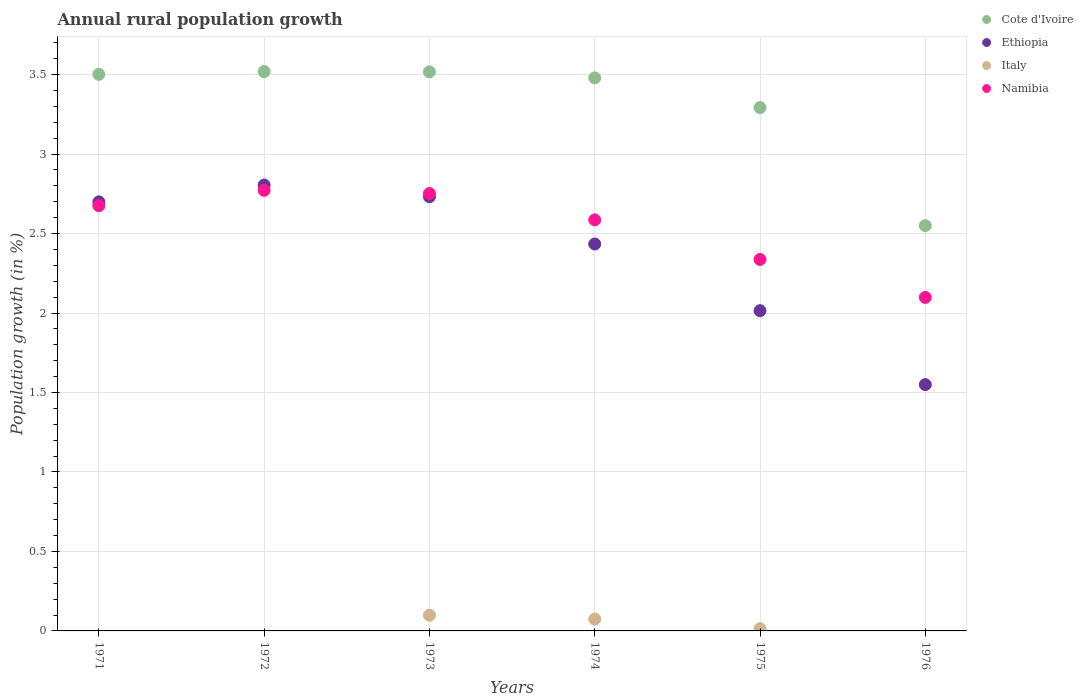How many different coloured dotlines are there?
Your answer should be very brief. 4. Is the number of dotlines equal to the number of legend labels?
Provide a succinct answer. No. What is the percentage of rural population growth in Namibia in 1971?
Keep it short and to the point. 2.68. Across all years, what is the maximum percentage of rural population growth in Namibia?
Provide a succinct answer. 2.77. Across all years, what is the minimum percentage of rural population growth in Ethiopia?
Offer a terse response. 1.55. What is the total percentage of rural population growth in Ethiopia in the graph?
Give a very brief answer. 14.23. What is the difference between the percentage of rural population growth in Cote d'Ivoire in 1974 and that in 1975?
Offer a very short reply. 0.19. What is the difference between the percentage of rural population growth in Cote d'Ivoire in 1973 and the percentage of rural population growth in Ethiopia in 1974?
Offer a very short reply. 1.08. What is the average percentage of rural population growth in Italy per year?
Your response must be concise. 0.03. In the year 1972, what is the difference between the percentage of rural population growth in Ethiopia and percentage of rural population growth in Cote d'Ivoire?
Offer a very short reply. -0.71. What is the ratio of the percentage of rural population growth in Ethiopia in 1972 to that in 1973?
Give a very brief answer. 1.03. Is the percentage of rural population growth in Cote d'Ivoire in 1972 less than that in 1973?
Make the answer very short. No. Is the difference between the percentage of rural population growth in Ethiopia in 1971 and 1976 greater than the difference between the percentage of rural population growth in Cote d'Ivoire in 1971 and 1976?
Keep it short and to the point. Yes. What is the difference between the highest and the second highest percentage of rural population growth in Italy?
Give a very brief answer. 0.02. What is the difference between the highest and the lowest percentage of rural population growth in Italy?
Your answer should be very brief. 0.1. In how many years, is the percentage of rural population growth in Ethiopia greater than the average percentage of rural population growth in Ethiopia taken over all years?
Your response must be concise. 4. Does the percentage of rural population growth in Cote d'Ivoire monotonically increase over the years?
Ensure brevity in your answer.  No. Is the percentage of rural population growth in Ethiopia strictly greater than the percentage of rural population growth in Italy over the years?
Give a very brief answer. Yes. How many years are there in the graph?
Provide a succinct answer. 6. What is the difference between two consecutive major ticks on the Y-axis?
Your answer should be compact. 0.5. Does the graph contain any zero values?
Your answer should be very brief. Yes. How many legend labels are there?
Provide a short and direct response. 4. How are the legend labels stacked?
Your response must be concise. Vertical. What is the title of the graph?
Keep it short and to the point. Annual rural population growth. Does "Grenada" appear as one of the legend labels in the graph?
Provide a short and direct response. No. What is the label or title of the X-axis?
Your answer should be compact. Years. What is the label or title of the Y-axis?
Make the answer very short. Population growth (in %). What is the Population growth (in %) in Cote d'Ivoire in 1971?
Your answer should be very brief. 3.5. What is the Population growth (in %) in Ethiopia in 1971?
Your response must be concise. 2.7. What is the Population growth (in %) in Italy in 1971?
Provide a short and direct response. 0. What is the Population growth (in %) in Namibia in 1971?
Provide a short and direct response. 2.68. What is the Population growth (in %) of Cote d'Ivoire in 1972?
Offer a very short reply. 3.52. What is the Population growth (in %) of Ethiopia in 1972?
Ensure brevity in your answer.  2.81. What is the Population growth (in %) in Italy in 1972?
Ensure brevity in your answer.  0. What is the Population growth (in %) of Namibia in 1972?
Your answer should be very brief. 2.77. What is the Population growth (in %) of Cote d'Ivoire in 1973?
Your response must be concise. 3.52. What is the Population growth (in %) of Ethiopia in 1973?
Keep it short and to the point. 2.73. What is the Population growth (in %) of Italy in 1973?
Offer a very short reply. 0.1. What is the Population growth (in %) of Namibia in 1973?
Your answer should be very brief. 2.75. What is the Population growth (in %) of Cote d'Ivoire in 1974?
Offer a very short reply. 3.48. What is the Population growth (in %) of Ethiopia in 1974?
Offer a very short reply. 2.43. What is the Population growth (in %) of Italy in 1974?
Offer a terse response. 0.07. What is the Population growth (in %) of Namibia in 1974?
Give a very brief answer. 2.59. What is the Population growth (in %) in Cote d'Ivoire in 1975?
Your answer should be compact. 3.29. What is the Population growth (in %) of Ethiopia in 1975?
Provide a succinct answer. 2.01. What is the Population growth (in %) in Italy in 1975?
Provide a short and direct response. 0.01. What is the Population growth (in %) in Namibia in 1975?
Provide a short and direct response. 2.34. What is the Population growth (in %) of Cote d'Ivoire in 1976?
Offer a very short reply. 2.55. What is the Population growth (in %) in Ethiopia in 1976?
Your response must be concise. 1.55. What is the Population growth (in %) in Italy in 1976?
Your answer should be compact. 0. What is the Population growth (in %) of Namibia in 1976?
Your answer should be very brief. 2.1. Across all years, what is the maximum Population growth (in %) of Cote d'Ivoire?
Your response must be concise. 3.52. Across all years, what is the maximum Population growth (in %) of Ethiopia?
Offer a terse response. 2.81. Across all years, what is the maximum Population growth (in %) in Italy?
Offer a very short reply. 0.1. Across all years, what is the maximum Population growth (in %) of Namibia?
Provide a succinct answer. 2.77. Across all years, what is the minimum Population growth (in %) in Cote d'Ivoire?
Your answer should be very brief. 2.55. Across all years, what is the minimum Population growth (in %) in Ethiopia?
Provide a short and direct response. 1.55. Across all years, what is the minimum Population growth (in %) in Namibia?
Provide a succinct answer. 2.1. What is the total Population growth (in %) in Cote d'Ivoire in the graph?
Provide a succinct answer. 19.86. What is the total Population growth (in %) in Ethiopia in the graph?
Make the answer very short. 14.23. What is the total Population growth (in %) in Italy in the graph?
Provide a short and direct response. 0.19. What is the total Population growth (in %) in Namibia in the graph?
Provide a short and direct response. 15.22. What is the difference between the Population growth (in %) of Cote d'Ivoire in 1971 and that in 1972?
Make the answer very short. -0.02. What is the difference between the Population growth (in %) of Ethiopia in 1971 and that in 1972?
Your answer should be very brief. -0.11. What is the difference between the Population growth (in %) in Namibia in 1971 and that in 1972?
Give a very brief answer. -0.1. What is the difference between the Population growth (in %) in Cote d'Ivoire in 1971 and that in 1973?
Offer a very short reply. -0.02. What is the difference between the Population growth (in %) of Ethiopia in 1971 and that in 1973?
Your answer should be compact. -0.03. What is the difference between the Population growth (in %) in Namibia in 1971 and that in 1973?
Give a very brief answer. -0.08. What is the difference between the Population growth (in %) of Cote d'Ivoire in 1971 and that in 1974?
Keep it short and to the point. 0.02. What is the difference between the Population growth (in %) in Ethiopia in 1971 and that in 1974?
Your answer should be compact. 0.27. What is the difference between the Population growth (in %) of Namibia in 1971 and that in 1974?
Ensure brevity in your answer.  0.09. What is the difference between the Population growth (in %) of Cote d'Ivoire in 1971 and that in 1975?
Your response must be concise. 0.21. What is the difference between the Population growth (in %) in Ethiopia in 1971 and that in 1975?
Offer a very short reply. 0.68. What is the difference between the Population growth (in %) in Namibia in 1971 and that in 1975?
Your response must be concise. 0.34. What is the difference between the Population growth (in %) of Cote d'Ivoire in 1971 and that in 1976?
Ensure brevity in your answer.  0.95. What is the difference between the Population growth (in %) in Ethiopia in 1971 and that in 1976?
Provide a short and direct response. 1.15. What is the difference between the Population growth (in %) in Namibia in 1971 and that in 1976?
Keep it short and to the point. 0.58. What is the difference between the Population growth (in %) in Cote d'Ivoire in 1972 and that in 1973?
Make the answer very short. 0. What is the difference between the Population growth (in %) of Ethiopia in 1972 and that in 1973?
Provide a short and direct response. 0.07. What is the difference between the Population growth (in %) of Namibia in 1972 and that in 1973?
Keep it short and to the point. 0.02. What is the difference between the Population growth (in %) of Cote d'Ivoire in 1972 and that in 1974?
Your answer should be compact. 0.04. What is the difference between the Population growth (in %) in Ethiopia in 1972 and that in 1974?
Ensure brevity in your answer.  0.37. What is the difference between the Population growth (in %) in Namibia in 1972 and that in 1974?
Provide a short and direct response. 0.19. What is the difference between the Population growth (in %) of Cote d'Ivoire in 1972 and that in 1975?
Keep it short and to the point. 0.23. What is the difference between the Population growth (in %) of Ethiopia in 1972 and that in 1975?
Your answer should be compact. 0.79. What is the difference between the Population growth (in %) of Namibia in 1972 and that in 1975?
Offer a very short reply. 0.43. What is the difference between the Population growth (in %) in Cote d'Ivoire in 1972 and that in 1976?
Keep it short and to the point. 0.97. What is the difference between the Population growth (in %) of Ethiopia in 1972 and that in 1976?
Keep it short and to the point. 1.26. What is the difference between the Population growth (in %) in Namibia in 1972 and that in 1976?
Give a very brief answer. 0.67. What is the difference between the Population growth (in %) of Cote d'Ivoire in 1973 and that in 1974?
Provide a short and direct response. 0.04. What is the difference between the Population growth (in %) of Ethiopia in 1973 and that in 1974?
Make the answer very short. 0.3. What is the difference between the Population growth (in %) of Italy in 1973 and that in 1974?
Your response must be concise. 0.02. What is the difference between the Population growth (in %) of Namibia in 1973 and that in 1974?
Ensure brevity in your answer.  0.17. What is the difference between the Population growth (in %) of Cote d'Ivoire in 1973 and that in 1975?
Keep it short and to the point. 0.23. What is the difference between the Population growth (in %) of Ethiopia in 1973 and that in 1975?
Make the answer very short. 0.72. What is the difference between the Population growth (in %) of Italy in 1973 and that in 1975?
Keep it short and to the point. 0.08. What is the difference between the Population growth (in %) in Namibia in 1973 and that in 1975?
Offer a very short reply. 0.41. What is the difference between the Population growth (in %) in Cote d'Ivoire in 1973 and that in 1976?
Your answer should be very brief. 0.97. What is the difference between the Population growth (in %) of Ethiopia in 1973 and that in 1976?
Keep it short and to the point. 1.18. What is the difference between the Population growth (in %) of Namibia in 1973 and that in 1976?
Keep it short and to the point. 0.65. What is the difference between the Population growth (in %) of Cote d'Ivoire in 1974 and that in 1975?
Your answer should be compact. 0.19. What is the difference between the Population growth (in %) of Ethiopia in 1974 and that in 1975?
Your answer should be compact. 0.42. What is the difference between the Population growth (in %) of Italy in 1974 and that in 1975?
Your answer should be compact. 0.06. What is the difference between the Population growth (in %) of Namibia in 1974 and that in 1975?
Provide a succinct answer. 0.25. What is the difference between the Population growth (in %) of Cote d'Ivoire in 1974 and that in 1976?
Provide a succinct answer. 0.93. What is the difference between the Population growth (in %) in Ethiopia in 1974 and that in 1976?
Give a very brief answer. 0.88. What is the difference between the Population growth (in %) of Namibia in 1974 and that in 1976?
Offer a very short reply. 0.49. What is the difference between the Population growth (in %) in Cote d'Ivoire in 1975 and that in 1976?
Your answer should be compact. 0.74. What is the difference between the Population growth (in %) in Ethiopia in 1975 and that in 1976?
Make the answer very short. 0.46. What is the difference between the Population growth (in %) of Namibia in 1975 and that in 1976?
Provide a succinct answer. 0.24. What is the difference between the Population growth (in %) in Cote d'Ivoire in 1971 and the Population growth (in %) in Ethiopia in 1972?
Make the answer very short. 0.7. What is the difference between the Population growth (in %) of Cote d'Ivoire in 1971 and the Population growth (in %) of Namibia in 1972?
Your answer should be very brief. 0.73. What is the difference between the Population growth (in %) in Ethiopia in 1971 and the Population growth (in %) in Namibia in 1972?
Give a very brief answer. -0.07. What is the difference between the Population growth (in %) in Cote d'Ivoire in 1971 and the Population growth (in %) in Ethiopia in 1973?
Your answer should be compact. 0.77. What is the difference between the Population growth (in %) of Cote d'Ivoire in 1971 and the Population growth (in %) of Italy in 1973?
Your answer should be compact. 3.4. What is the difference between the Population growth (in %) in Cote d'Ivoire in 1971 and the Population growth (in %) in Namibia in 1973?
Offer a terse response. 0.75. What is the difference between the Population growth (in %) in Ethiopia in 1971 and the Population growth (in %) in Italy in 1973?
Ensure brevity in your answer.  2.6. What is the difference between the Population growth (in %) in Ethiopia in 1971 and the Population growth (in %) in Namibia in 1973?
Offer a terse response. -0.05. What is the difference between the Population growth (in %) of Cote d'Ivoire in 1971 and the Population growth (in %) of Ethiopia in 1974?
Provide a succinct answer. 1.07. What is the difference between the Population growth (in %) of Cote d'Ivoire in 1971 and the Population growth (in %) of Italy in 1974?
Offer a terse response. 3.43. What is the difference between the Population growth (in %) in Cote d'Ivoire in 1971 and the Population growth (in %) in Namibia in 1974?
Your answer should be compact. 0.92. What is the difference between the Population growth (in %) in Ethiopia in 1971 and the Population growth (in %) in Italy in 1974?
Provide a short and direct response. 2.62. What is the difference between the Population growth (in %) of Ethiopia in 1971 and the Population growth (in %) of Namibia in 1974?
Keep it short and to the point. 0.11. What is the difference between the Population growth (in %) in Cote d'Ivoire in 1971 and the Population growth (in %) in Ethiopia in 1975?
Offer a very short reply. 1.49. What is the difference between the Population growth (in %) of Cote d'Ivoire in 1971 and the Population growth (in %) of Italy in 1975?
Keep it short and to the point. 3.49. What is the difference between the Population growth (in %) of Cote d'Ivoire in 1971 and the Population growth (in %) of Namibia in 1975?
Provide a succinct answer. 1.16. What is the difference between the Population growth (in %) in Ethiopia in 1971 and the Population growth (in %) in Italy in 1975?
Keep it short and to the point. 2.69. What is the difference between the Population growth (in %) of Ethiopia in 1971 and the Population growth (in %) of Namibia in 1975?
Provide a short and direct response. 0.36. What is the difference between the Population growth (in %) in Cote d'Ivoire in 1971 and the Population growth (in %) in Ethiopia in 1976?
Your answer should be compact. 1.95. What is the difference between the Population growth (in %) in Cote d'Ivoire in 1971 and the Population growth (in %) in Namibia in 1976?
Make the answer very short. 1.4. What is the difference between the Population growth (in %) in Ethiopia in 1971 and the Population growth (in %) in Namibia in 1976?
Provide a succinct answer. 0.6. What is the difference between the Population growth (in %) in Cote d'Ivoire in 1972 and the Population growth (in %) in Ethiopia in 1973?
Offer a terse response. 0.79. What is the difference between the Population growth (in %) in Cote d'Ivoire in 1972 and the Population growth (in %) in Italy in 1973?
Ensure brevity in your answer.  3.42. What is the difference between the Population growth (in %) of Cote d'Ivoire in 1972 and the Population growth (in %) of Namibia in 1973?
Provide a succinct answer. 0.77. What is the difference between the Population growth (in %) in Ethiopia in 1972 and the Population growth (in %) in Italy in 1973?
Provide a succinct answer. 2.71. What is the difference between the Population growth (in %) in Ethiopia in 1972 and the Population growth (in %) in Namibia in 1973?
Keep it short and to the point. 0.05. What is the difference between the Population growth (in %) of Cote d'Ivoire in 1972 and the Population growth (in %) of Ethiopia in 1974?
Your response must be concise. 1.08. What is the difference between the Population growth (in %) in Cote d'Ivoire in 1972 and the Population growth (in %) in Italy in 1974?
Provide a succinct answer. 3.44. What is the difference between the Population growth (in %) in Cote d'Ivoire in 1972 and the Population growth (in %) in Namibia in 1974?
Offer a terse response. 0.93. What is the difference between the Population growth (in %) of Ethiopia in 1972 and the Population growth (in %) of Italy in 1974?
Provide a short and direct response. 2.73. What is the difference between the Population growth (in %) of Ethiopia in 1972 and the Population growth (in %) of Namibia in 1974?
Your answer should be very brief. 0.22. What is the difference between the Population growth (in %) in Cote d'Ivoire in 1972 and the Population growth (in %) in Ethiopia in 1975?
Offer a terse response. 1.5. What is the difference between the Population growth (in %) in Cote d'Ivoire in 1972 and the Population growth (in %) in Italy in 1975?
Your response must be concise. 3.51. What is the difference between the Population growth (in %) of Cote d'Ivoire in 1972 and the Population growth (in %) of Namibia in 1975?
Keep it short and to the point. 1.18. What is the difference between the Population growth (in %) of Ethiopia in 1972 and the Population growth (in %) of Italy in 1975?
Your answer should be compact. 2.79. What is the difference between the Population growth (in %) in Ethiopia in 1972 and the Population growth (in %) in Namibia in 1975?
Provide a short and direct response. 0.47. What is the difference between the Population growth (in %) of Cote d'Ivoire in 1972 and the Population growth (in %) of Ethiopia in 1976?
Ensure brevity in your answer.  1.97. What is the difference between the Population growth (in %) of Cote d'Ivoire in 1972 and the Population growth (in %) of Namibia in 1976?
Your answer should be compact. 1.42. What is the difference between the Population growth (in %) in Ethiopia in 1972 and the Population growth (in %) in Namibia in 1976?
Offer a terse response. 0.71. What is the difference between the Population growth (in %) of Cote d'Ivoire in 1973 and the Population growth (in %) of Ethiopia in 1974?
Offer a terse response. 1.08. What is the difference between the Population growth (in %) in Cote d'Ivoire in 1973 and the Population growth (in %) in Italy in 1974?
Your answer should be compact. 3.44. What is the difference between the Population growth (in %) of Cote d'Ivoire in 1973 and the Population growth (in %) of Namibia in 1974?
Your answer should be compact. 0.93. What is the difference between the Population growth (in %) in Ethiopia in 1973 and the Population growth (in %) in Italy in 1974?
Give a very brief answer. 2.66. What is the difference between the Population growth (in %) of Ethiopia in 1973 and the Population growth (in %) of Namibia in 1974?
Offer a very short reply. 0.15. What is the difference between the Population growth (in %) of Italy in 1973 and the Population growth (in %) of Namibia in 1974?
Provide a succinct answer. -2.49. What is the difference between the Population growth (in %) in Cote d'Ivoire in 1973 and the Population growth (in %) in Ethiopia in 1975?
Provide a succinct answer. 1.5. What is the difference between the Population growth (in %) of Cote d'Ivoire in 1973 and the Population growth (in %) of Italy in 1975?
Offer a terse response. 3.5. What is the difference between the Population growth (in %) in Cote d'Ivoire in 1973 and the Population growth (in %) in Namibia in 1975?
Offer a very short reply. 1.18. What is the difference between the Population growth (in %) of Ethiopia in 1973 and the Population growth (in %) of Italy in 1975?
Provide a short and direct response. 2.72. What is the difference between the Population growth (in %) in Ethiopia in 1973 and the Population growth (in %) in Namibia in 1975?
Provide a short and direct response. 0.39. What is the difference between the Population growth (in %) of Italy in 1973 and the Population growth (in %) of Namibia in 1975?
Give a very brief answer. -2.24. What is the difference between the Population growth (in %) in Cote d'Ivoire in 1973 and the Population growth (in %) in Ethiopia in 1976?
Your answer should be very brief. 1.97. What is the difference between the Population growth (in %) of Cote d'Ivoire in 1973 and the Population growth (in %) of Namibia in 1976?
Provide a succinct answer. 1.42. What is the difference between the Population growth (in %) in Ethiopia in 1973 and the Population growth (in %) in Namibia in 1976?
Give a very brief answer. 0.63. What is the difference between the Population growth (in %) of Italy in 1973 and the Population growth (in %) of Namibia in 1976?
Your response must be concise. -2. What is the difference between the Population growth (in %) in Cote d'Ivoire in 1974 and the Population growth (in %) in Ethiopia in 1975?
Provide a short and direct response. 1.46. What is the difference between the Population growth (in %) of Cote d'Ivoire in 1974 and the Population growth (in %) of Italy in 1975?
Make the answer very short. 3.47. What is the difference between the Population growth (in %) in Cote d'Ivoire in 1974 and the Population growth (in %) in Namibia in 1975?
Provide a succinct answer. 1.14. What is the difference between the Population growth (in %) of Ethiopia in 1974 and the Population growth (in %) of Italy in 1975?
Make the answer very short. 2.42. What is the difference between the Population growth (in %) of Ethiopia in 1974 and the Population growth (in %) of Namibia in 1975?
Your answer should be compact. 0.1. What is the difference between the Population growth (in %) of Italy in 1974 and the Population growth (in %) of Namibia in 1975?
Your response must be concise. -2.26. What is the difference between the Population growth (in %) in Cote d'Ivoire in 1974 and the Population growth (in %) in Ethiopia in 1976?
Give a very brief answer. 1.93. What is the difference between the Population growth (in %) of Cote d'Ivoire in 1974 and the Population growth (in %) of Namibia in 1976?
Ensure brevity in your answer.  1.38. What is the difference between the Population growth (in %) in Ethiopia in 1974 and the Population growth (in %) in Namibia in 1976?
Ensure brevity in your answer.  0.34. What is the difference between the Population growth (in %) in Italy in 1974 and the Population growth (in %) in Namibia in 1976?
Your answer should be very brief. -2.02. What is the difference between the Population growth (in %) of Cote d'Ivoire in 1975 and the Population growth (in %) of Ethiopia in 1976?
Ensure brevity in your answer.  1.74. What is the difference between the Population growth (in %) in Cote d'Ivoire in 1975 and the Population growth (in %) in Namibia in 1976?
Your response must be concise. 1.19. What is the difference between the Population growth (in %) in Ethiopia in 1975 and the Population growth (in %) in Namibia in 1976?
Keep it short and to the point. -0.08. What is the difference between the Population growth (in %) of Italy in 1975 and the Population growth (in %) of Namibia in 1976?
Your response must be concise. -2.08. What is the average Population growth (in %) in Cote d'Ivoire per year?
Give a very brief answer. 3.31. What is the average Population growth (in %) in Ethiopia per year?
Make the answer very short. 2.37. What is the average Population growth (in %) in Italy per year?
Give a very brief answer. 0.03. What is the average Population growth (in %) of Namibia per year?
Make the answer very short. 2.54. In the year 1971, what is the difference between the Population growth (in %) of Cote d'Ivoire and Population growth (in %) of Ethiopia?
Ensure brevity in your answer.  0.8. In the year 1971, what is the difference between the Population growth (in %) in Cote d'Ivoire and Population growth (in %) in Namibia?
Make the answer very short. 0.83. In the year 1971, what is the difference between the Population growth (in %) in Ethiopia and Population growth (in %) in Namibia?
Give a very brief answer. 0.02. In the year 1972, what is the difference between the Population growth (in %) of Cote d'Ivoire and Population growth (in %) of Ethiopia?
Ensure brevity in your answer.  0.71. In the year 1972, what is the difference between the Population growth (in %) of Cote d'Ivoire and Population growth (in %) of Namibia?
Ensure brevity in your answer.  0.75. In the year 1972, what is the difference between the Population growth (in %) in Ethiopia and Population growth (in %) in Namibia?
Provide a succinct answer. 0.03. In the year 1973, what is the difference between the Population growth (in %) in Cote d'Ivoire and Population growth (in %) in Ethiopia?
Offer a terse response. 0.79. In the year 1973, what is the difference between the Population growth (in %) of Cote d'Ivoire and Population growth (in %) of Italy?
Your answer should be very brief. 3.42. In the year 1973, what is the difference between the Population growth (in %) in Cote d'Ivoire and Population growth (in %) in Namibia?
Your answer should be compact. 0.77. In the year 1973, what is the difference between the Population growth (in %) of Ethiopia and Population growth (in %) of Italy?
Offer a very short reply. 2.63. In the year 1973, what is the difference between the Population growth (in %) in Ethiopia and Population growth (in %) in Namibia?
Ensure brevity in your answer.  -0.02. In the year 1973, what is the difference between the Population growth (in %) of Italy and Population growth (in %) of Namibia?
Your answer should be very brief. -2.65. In the year 1974, what is the difference between the Population growth (in %) of Cote d'Ivoire and Population growth (in %) of Ethiopia?
Your answer should be very brief. 1.05. In the year 1974, what is the difference between the Population growth (in %) of Cote d'Ivoire and Population growth (in %) of Italy?
Give a very brief answer. 3.4. In the year 1974, what is the difference between the Population growth (in %) in Cote d'Ivoire and Population growth (in %) in Namibia?
Your answer should be compact. 0.89. In the year 1974, what is the difference between the Population growth (in %) in Ethiopia and Population growth (in %) in Italy?
Your answer should be very brief. 2.36. In the year 1974, what is the difference between the Population growth (in %) of Ethiopia and Population growth (in %) of Namibia?
Provide a succinct answer. -0.15. In the year 1974, what is the difference between the Population growth (in %) of Italy and Population growth (in %) of Namibia?
Offer a terse response. -2.51. In the year 1975, what is the difference between the Population growth (in %) of Cote d'Ivoire and Population growth (in %) of Ethiopia?
Provide a short and direct response. 1.28. In the year 1975, what is the difference between the Population growth (in %) in Cote d'Ivoire and Population growth (in %) in Italy?
Ensure brevity in your answer.  3.28. In the year 1975, what is the difference between the Population growth (in %) in Cote d'Ivoire and Population growth (in %) in Namibia?
Give a very brief answer. 0.96. In the year 1975, what is the difference between the Population growth (in %) of Ethiopia and Population growth (in %) of Italy?
Your response must be concise. 2. In the year 1975, what is the difference between the Population growth (in %) of Ethiopia and Population growth (in %) of Namibia?
Offer a very short reply. -0.32. In the year 1975, what is the difference between the Population growth (in %) in Italy and Population growth (in %) in Namibia?
Make the answer very short. -2.32. In the year 1976, what is the difference between the Population growth (in %) in Cote d'Ivoire and Population growth (in %) in Namibia?
Keep it short and to the point. 0.45. In the year 1976, what is the difference between the Population growth (in %) in Ethiopia and Population growth (in %) in Namibia?
Provide a short and direct response. -0.55. What is the ratio of the Population growth (in %) in Ethiopia in 1971 to that in 1972?
Your answer should be compact. 0.96. What is the ratio of the Population growth (in %) of Namibia in 1971 to that in 1972?
Your response must be concise. 0.97. What is the ratio of the Population growth (in %) in Cote d'Ivoire in 1971 to that in 1973?
Keep it short and to the point. 1. What is the ratio of the Population growth (in %) of Ethiopia in 1971 to that in 1973?
Your answer should be very brief. 0.99. What is the ratio of the Population growth (in %) in Namibia in 1971 to that in 1973?
Your response must be concise. 0.97. What is the ratio of the Population growth (in %) in Cote d'Ivoire in 1971 to that in 1974?
Your answer should be compact. 1.01. What is the ratio of the Population growth (in %) of Ethiopia in 1971 to that in 1974?
Provide a short and direct response. 1.11. What is the ratio of the Population growth (in %) of Namibia in 1971 to that in 1974?
Make the answer very short. 1.03. What is the ratio of the Population growth (in %) of Cote d'Ivoire in 1971 to that in 1975?
Offer a terse response. 1.06. What is the ratio of the Population growth (in %) of Ethiopia in 1971 to that in 1975?
Give a very brief answer. 1.34. What is the ratio of the Population growth (in %) in Namibia in 1971 to that in 1975?
Keep it short and to the point. 1.14. What is the ratio of the Population growth (in %) in Cote d'Ivoire in 1971 to that in 1976?
Keep it short and to the point. 1.37. What is the ratio of the Population growth (in %) of Ethiopia in 1971 to that in 1976?
Ensure brevity in your answer.  1.74. What is the ratio of the Population growth (in %) of Namibia in 1971 to that in 1976?
Provide a succinct answer. 1.28. What is the ratio of the Population growth (in %) in Cote d'Ivoire in 1972 to that in 1973?
Provide a succinct answer. 1. What is the ratio of the Population growth (in %) of Ethiopia in 1972 to that in 1973?
Offer a very short reply. 1.03. What is the ratio of the Population growth (in %) of Namibia in 1972 to that in 1973?
Provide a succinct answer. 1.01. What is the ratio of the Population growth (in %) in Cote d'Ivoire in 1972 to that in 1974?
Offer a very short reply. 1.01. What is the ratio of the Population growth (in %) in Ethiopia in 1972 to that in 1974?
Provide a succinct answer. 1.15. What is the ratio of the Population growth (in %) of Namibia in 1972 to that in 1974?
Keep it short and to the point. 1.07. What is the ratio of the Population growth (in %) in Cote d'Ivoire in 1972 to that in 1975?
Your response must be concise. 1.07. What is the ratio of the Population growth (in %) of Ethiopia in 1972 to that in 1975?
Ensure brevity in your answer.  1.39. What is the ratio of the Population growth (in %) in Namibia in 1972 to that in 1975?
Give a very brief answer. 1.19. What is the ratio of the Population growth (in %) in Cote d'Ivoire in 1972 to that in 1976?
Provide a succinct answer. 1.38. What is the ratio of the Population growth (in %) in Ethiopia in 1972 to that in 1976?
Your response must be concise. 1.81. What is the ratio of the Population growth (in %) of Namibia in 1972 to that in 1976?
Keep it short and to the point. 1.32. What is the ratio of the Population growth (in %) in Cote d'Ivoire in 1973 to that in 1974?
Offer a very short reply. 1.01. What is the ratio of the Population growth (in %) in Ethiopia in 1973 to that in 1974?
Your answer should be compact. 1.12. What is the ratio of the Population growth (in %) in Italy in 1973 to that in 1974?
Provide a succinct answer. 1.33. What is the ratio of the Population growth (in %) in Namibia in 1973 to that in 1974?
Provide a succinct answer. 1.06. What is the ratio of the Population growth (in %) in Cote d'Ivoire in 1973 to that in 1975?
Give a very brief answer. 1.07. What is the ratio of the Population growth (in %) of Ethiopia in 1973 to that in 1975?
Make the answer very short. 1.36. What is the ratio of the Population growth (in %) of Italy in 1973 to that in 1975?
Your answer should be compact. 7.09. What is the ratio of the Population growth (in %) in Namibia in 1973 to that in 1975?
Provide a succinct answer. 1.18. What is the ratio of the Population growth (in %) in Cote d'Ivoire in 1973 to that in 1976?
Your response must be concise. 1.38. What is the ratio of the Population growth (in %) of Ethiopia in 1973 to that in 1976?
Give a very brief answer. 1.76. What is the ratio of the Population growth (in %) in Namibia in 1973 to that in 1976?
Your answer should be very brief. 1.31. What is the ratio of the Population growth (in %) in Cote d'Ivoire in 1974 to that in 1975?
Give a very brief answer. 1.06. What is the ratio of the Population growth (in %) of Ethiopia in 1974 to that in 1975?
Your answer should be very brief. 1.21. What is the ratio of the Population growth (in %) of Italy in 1974 to that in 1975?
Your answer should be compact. 5.35. What is the ratio of the Population growth (in %) in Namibia in 1974 to that in 1975?
Your response must be concise. 1.11. What is the ratio of the Population growth (in %) in Cote d'Ivoire in 1974 to that in 1976?
Your answer should be very brief. 1.36. What is the ratio of the Population growth (in %) of Ethiopia in 1974 to that in 1976?
Your answer should be very brief. 1.57. What is the ratio of the Population growth (in %) of Namibia in 1974 to that in 1976?
Offer a very short reply. 1.23. What is the ratio of the Population growth (in %) of Cote d'Ivoire in 1975 to that in 1976?
Keep it short and to the point. 1.29. What is the ratio of the Population growth (in %) of Ethiopia in 1975 to that in 1976?
Make the answer very short. 1.3. What is the ratio of the Population growth (in %) in Namibia in 1975 to that in 1976?
Keep it short and to the point. 1.11. What is the difference between the highest and the second highest Population growth (in %) in Cote d'Ivoire?
Provide a short and direct response. 0. What is the difference between the highest and the second highest Population growth (in %) in Ethiopia?
Your response must be concise. 0.07. What is the difference between the highest and the second highest Population growth (in %) of Italy?
Keep it short and to the point. 0.02. What is the difference between the highest and the second highest Population growth (in %) of Namibia?
Your response must be concise. 0.02. What is the difference between the highest and the lowest Population growth (in %) in Cote d'Ivoire?
Ensure brevity in your answer.  0.97. What is the difference between the highest and the lowest Population growth (in %) in Ethiopia?
Keep it short and to the point. 1.26. What is the difference between the highest and the lowest Population growth (in %) in Italy?
Ensure brevity in your answer.  0.1. What is the difference between the highest and the lowest Population growth (in %) of Namibia?
Offer a very short reply. 0.67. 